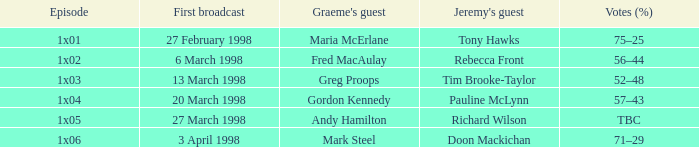When does jeremy feature pauline mclynn as a guest on his episode? 1x04. 